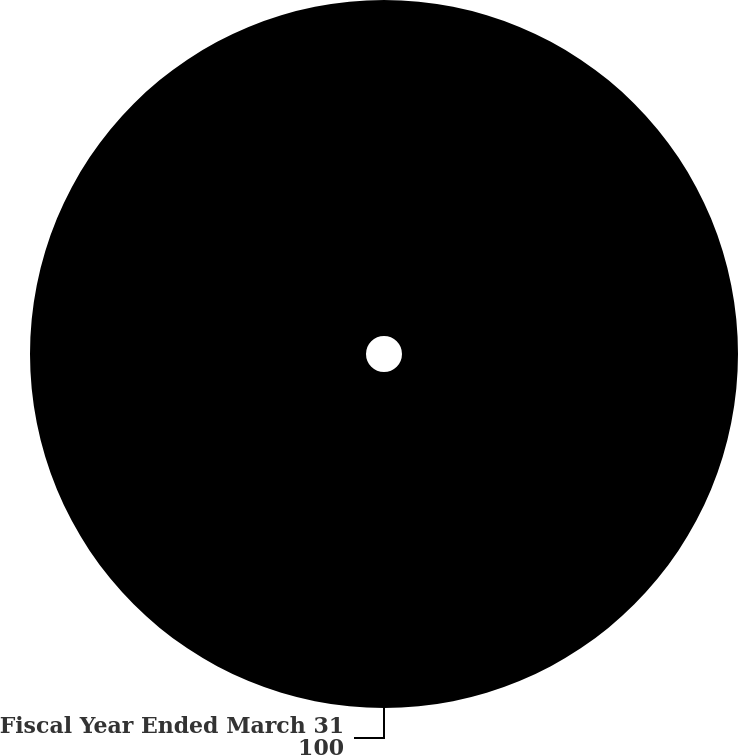Convert chart. <chart><loc_0><loc_0><loc_500><loc_500><pie_chart><fcel>Fiscal Year Ended March 31<nl><fcel>100.0%<nl></chart> 